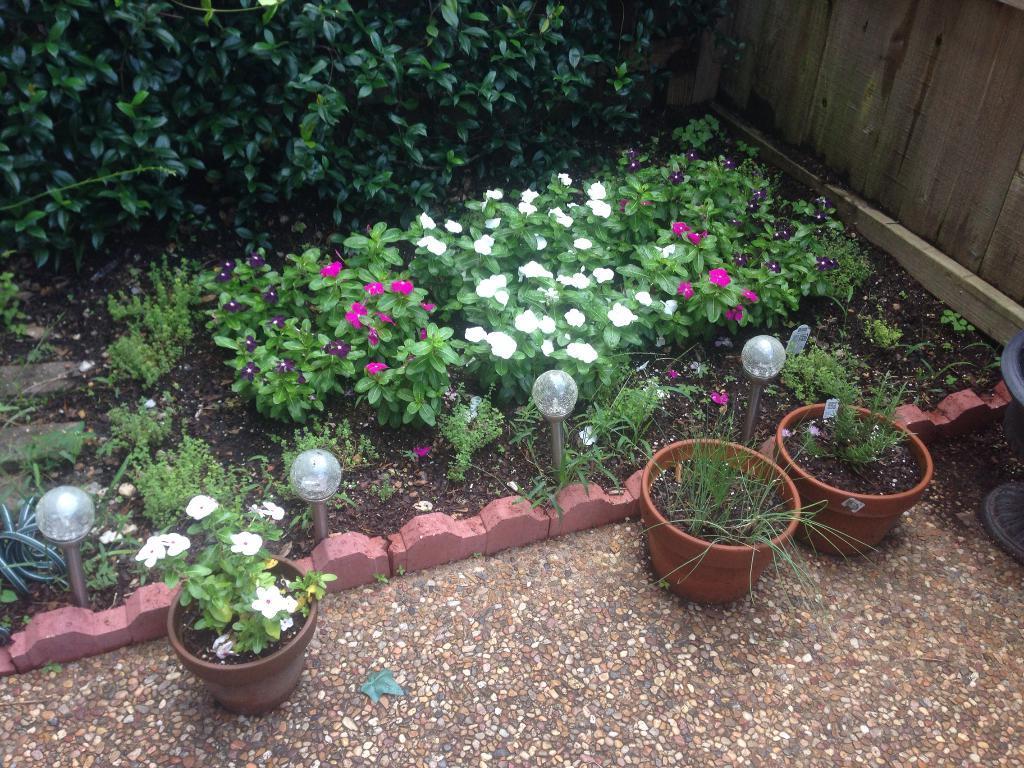How would you summarize this image in a sentence or two? In the foreground of the image we can see plants planted in pots, light poles. In the background, we can see group of flowers on plants and some trees and wooden fence. 